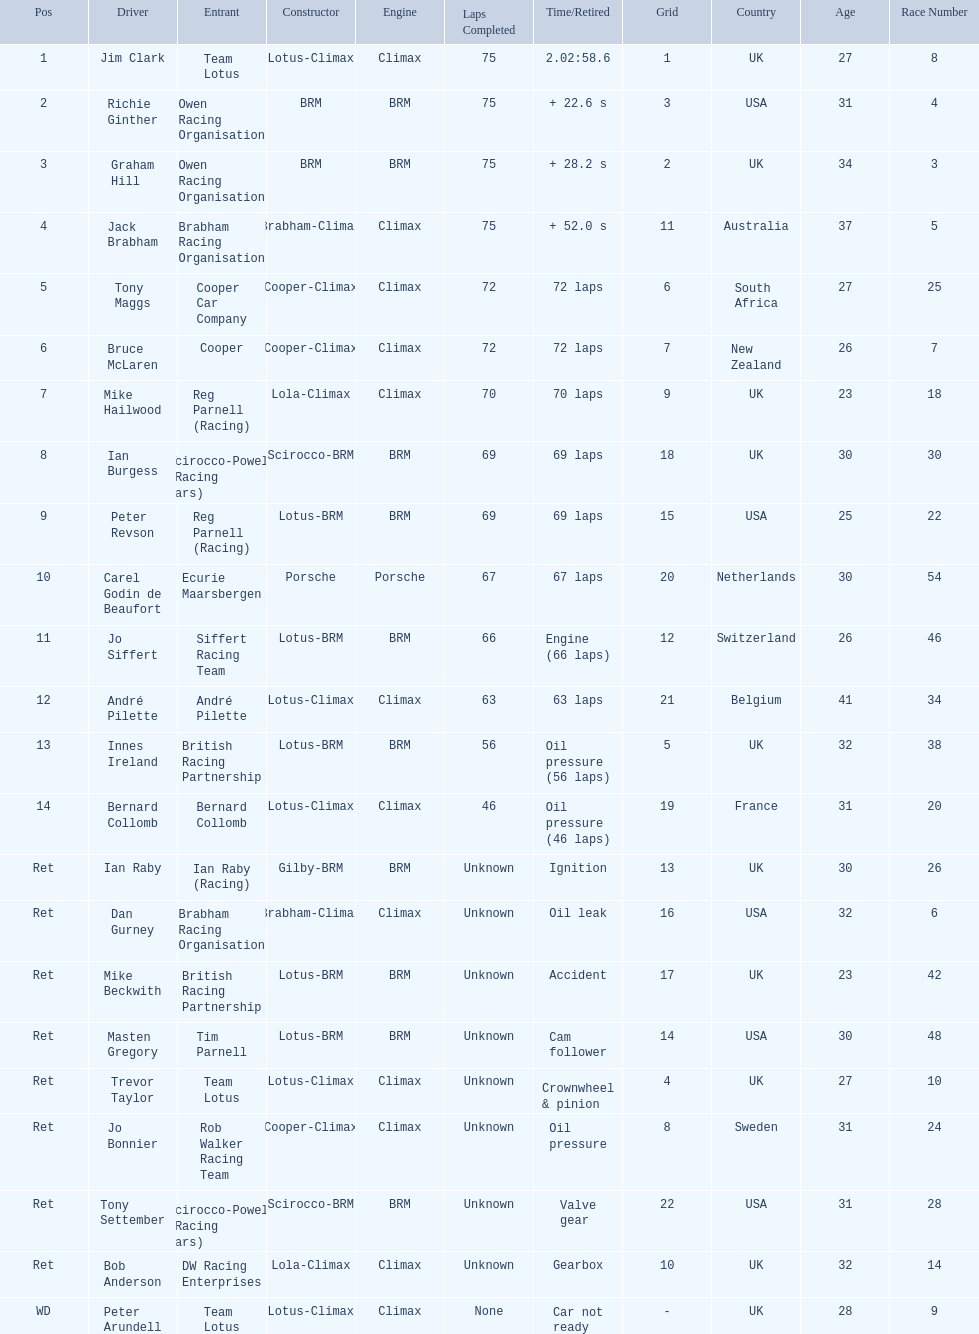What was the same problem that bernard collomb had as innes ireland? Oil pressure. 